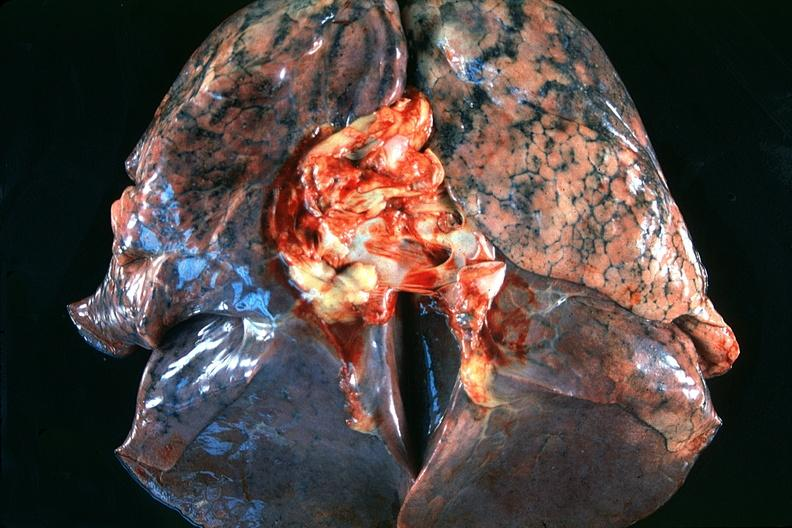does this image show normal lung?
Answer the question using a single word or phrase. Yes 